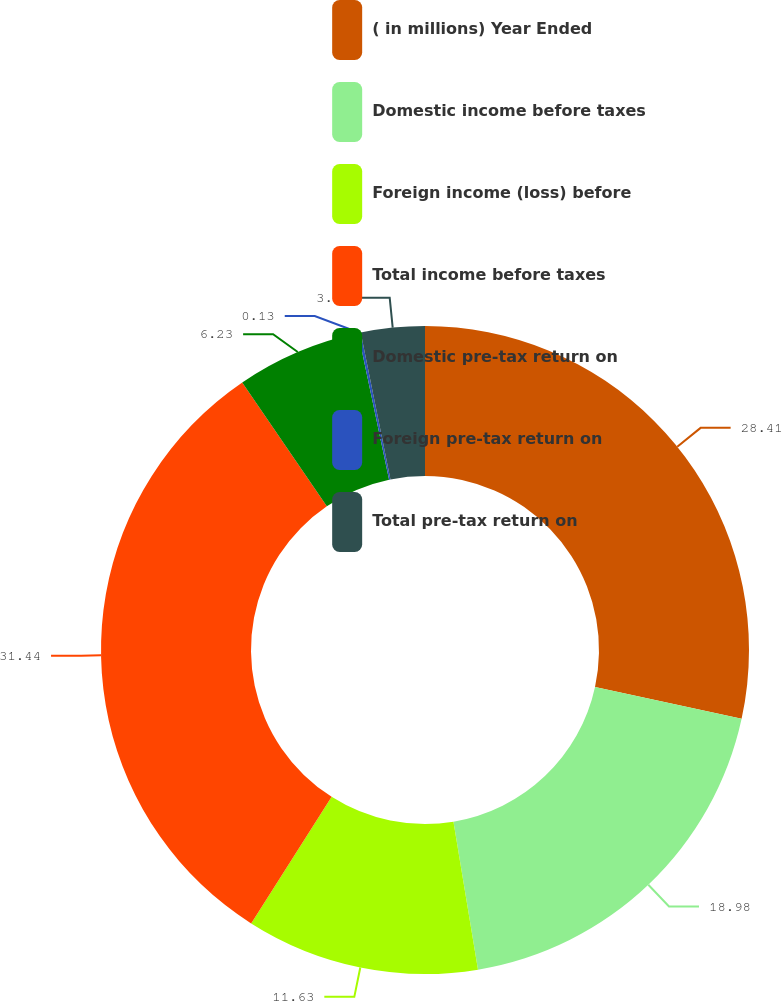Convert chart to OTSL. <chart><loc_0><loc_0><loc_500><loc_500><pie_chart><fcel>( in millions) Year Ended<fcel>Domestic income before taxes<fcel>Foreign income (loss) before<fcel>Total income before taxes<fcel>Domestic pre-tax return on<fcel>Foreign pre-tax return on<fcel>Total pre-tax return on<nl><fcel>28.41%<fcel>18.98%<fcel>11.63%<fcel>31.45%<fcel>6.23%<fcel>0.13%<fcel>3.18%<nl></chart> 